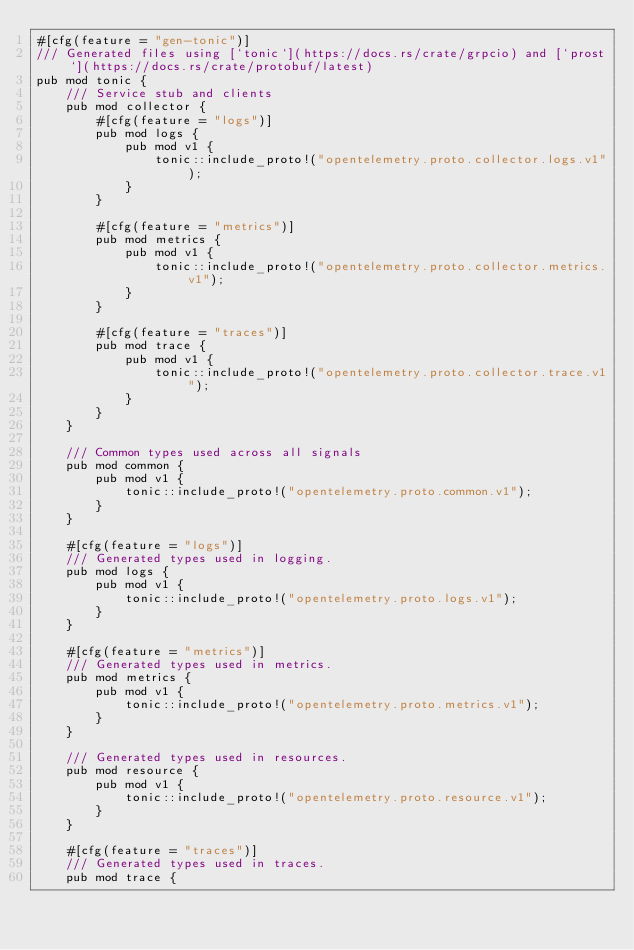Convert code to text. <code><loc_0><loc_0><loc_500><loc_500><_Rust_>#[cfg(feature = "gen-tonic")]
/// Generated files using [`tonic`](https://docs.rs/crate/grpcio) and [`prost`](https://docs.rs/crate/protobuf/latest)
pub mod tonic {
    /// Service stub and clients
    pub mod collector {
        #[cfg(feature = "logs")]
        pub mod logs {
            pub mod v1 {
                tonic::include_proto!("opentelemetry.proto.collector.logs.v1");
            }
        }

        #[cfg(feature = "metrics")]
        pub mod metrics {
            pub mod v1 {
                tonic::include_proto!("opentelemetry.proto.collector.metrics.v1");
            }
        }

        #[cfg(feature = "traces")]
        pub mod trace {
            pub mod v1 {
                tonic::include_proto!("opentelemetry.proto.collector.trace.v1");
            }
        }
    }

    /// Common types used across all signals
    pub mod common {
        pub mod v1 {
            tonic::include_proto!("opentelemetry.proto.common.v1");
        }
    }

    #[cfg(feature = "logs")]
    /// Generated types used in logging.
    pub mod logs {
        pub mod v1 {
            tonic::include_proto!("opentelemetry.proto.logs.v1");
        }
    }

    #[cfg(feature = "metrics")]
    /// Generated types used in metrics.
    pub mod metrics {
        pub mod v1 {
            tonic::include_proto!("opentelemetry.proto.metrics.v1");
        }
    }

    /// Generated types used in resources.
    pub mod resource {
        pub mod v1 {
            tonic::include_proto!("opentelemetry.proto.resource.v1");
        }
    }

    #[cfg(feature = "traces")]
    /// Generated types used in traces.
    pub mod trace {</code> 